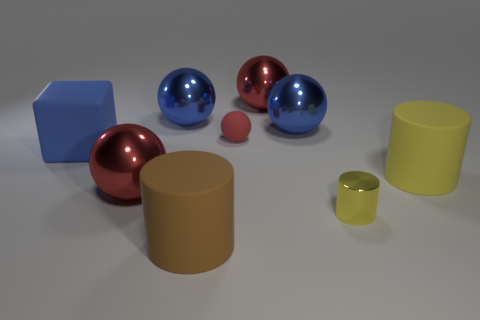Subtract all cyan cylinders. How many red spheres are left? 3 Subtract 2 spheres. How many spheres are left? 3 Subtract all green spheres. Subtract all yellow cylinders. How many spheres are left? 5 Add 1 cubes. How many objects exist? 10 Subtract all cubes. How many objects are left? 8 Add 3 cubes. How many cubes exist? 4 Subtract 1 brown cylinders. How many objects are left? 8 Subtract all purple metallic cylinders. Subtract all tiny cylinders. How many objects are left? 8 Add 1 red things. How many red things are left? 4 